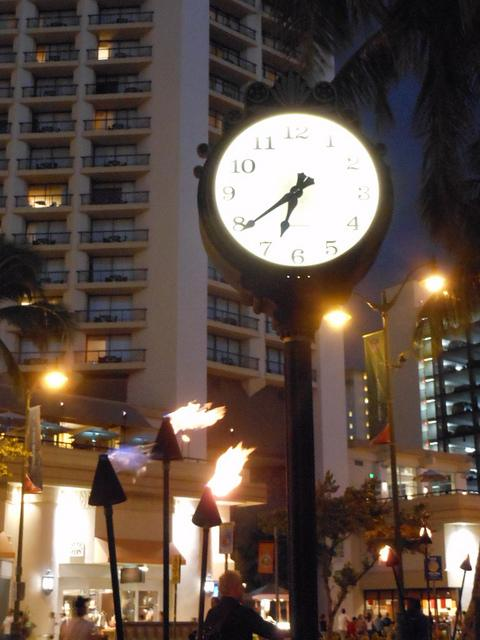In the event of a fire what could be blamed? Please explain your reasoning. torch. The torches are lit. 